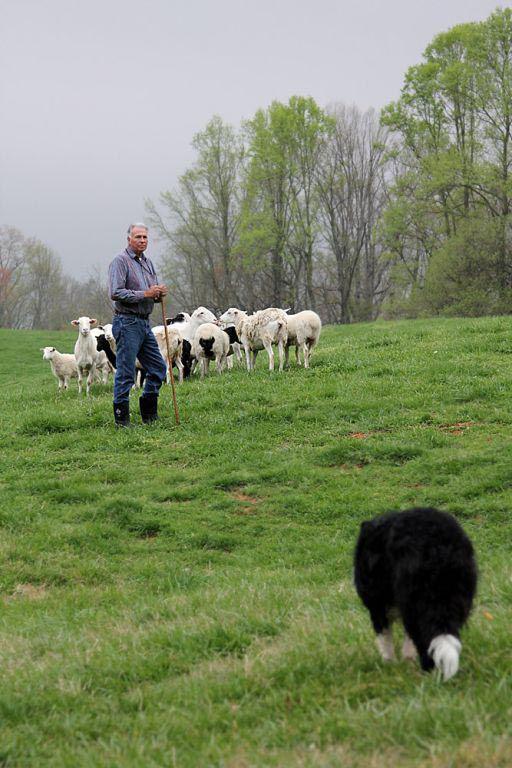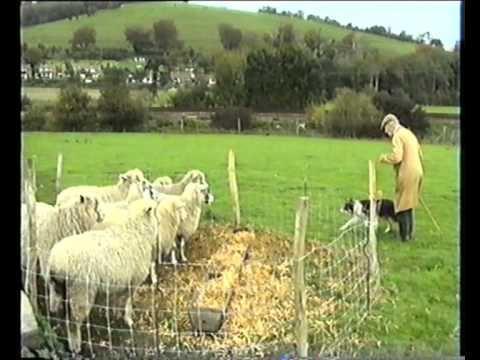The first image is the image on the left, the second image is the image on the right. Given the left and right images, does the statement "One image shows a dog herding water fowl." hold true? Answer yes or no. No. 